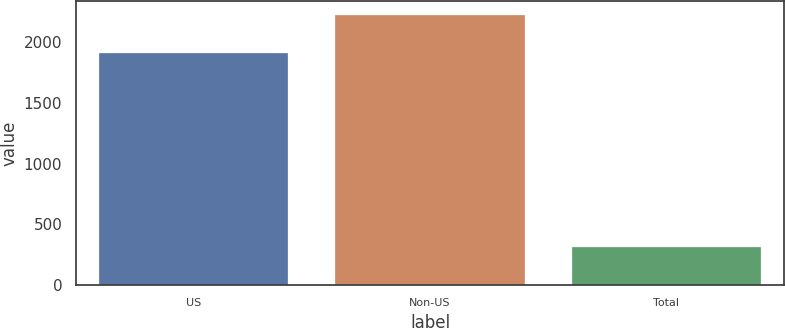<chart> <loc_0><loc_0><loc_500><loc_500><bar_chart><fcel>US<fcel>Non-US<fcel>Total<nl><fcel>1915<fcel>2229<fcel>314<nl></chart> 